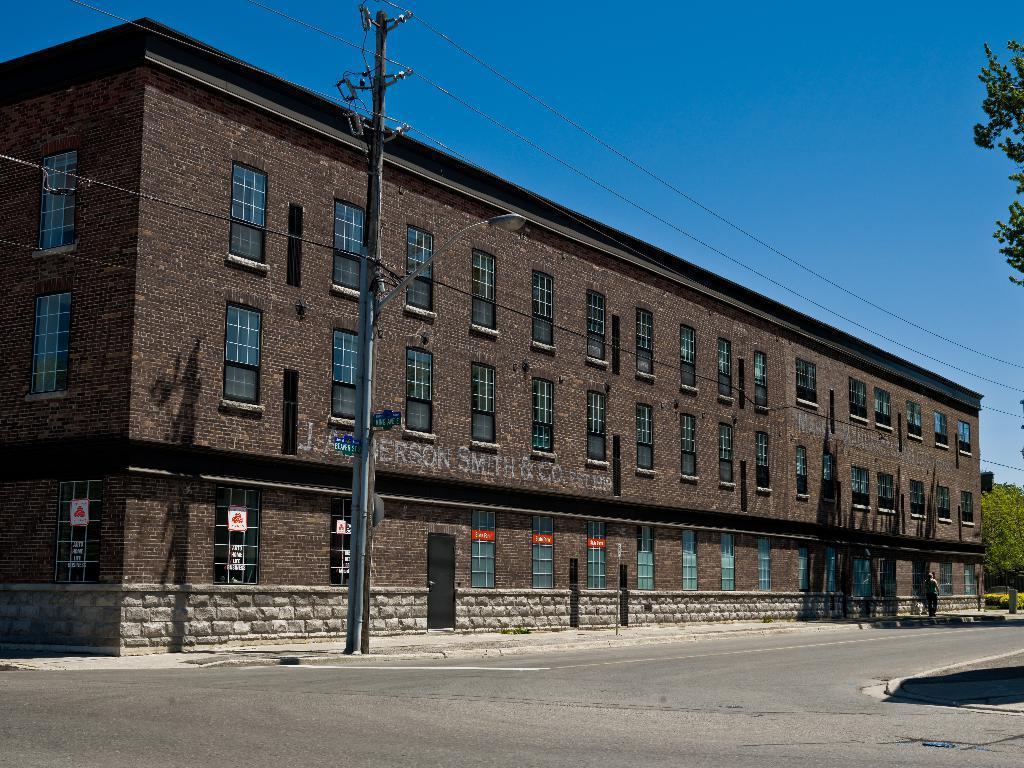Describe this image in one or two sentences. It is a building in brown color, at the bottom there is the road. At the top it is the blue color sky. 